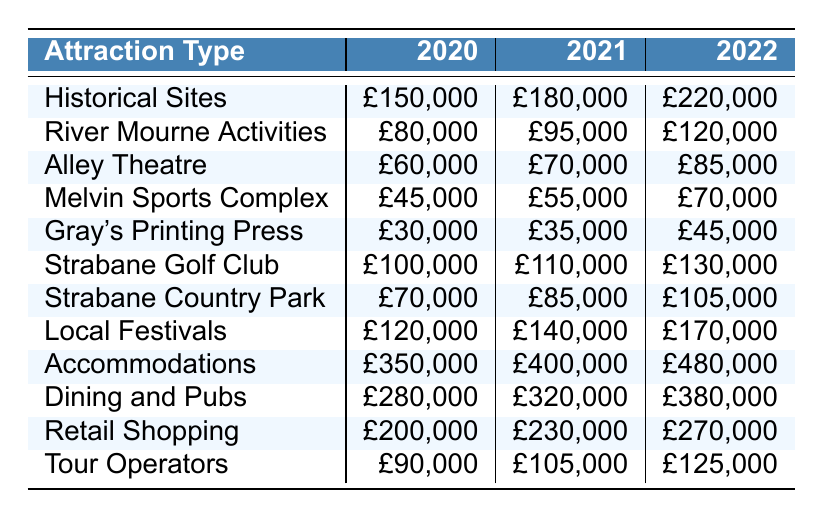What was the tourism revenue from Accommodations in 2022? The table shows that the revenue from Accommodations in 2022 is £480,000.
Answer: £480,000 Which attraction type had the highest revenue in 2021? By looking at the 2021 column, Accommodations has the highest revenue at £400,000.
Answer: Accommodations What is the total revenue from Dining and Pubs and Retail Shopping in 2020? The revenue for Dining and Pubs in 2020 is £280,000, and for Retail Shopping, it is £200,000. Summing these gives £280,000 + £200,000 = £480,000.
Answer: £480,000 Did the revenue from Strabane Golf Club increase from 2020 to 2021? The revenue in 2020 was £100,000, and in 2021 it increased to £110,000. Therefore, it did increase.
Answer: Yes What is the average revenue for Historical Sites over the three years? The revenues are £150,000, £180,000, and £220,000. The total is £150,000 + £180,000 + £220,000 = £550,000. The average is £550,000 / 3 = £183,333.33.
Answer: £183,333.33 What was the increase in revenue for River Mourne Activities from 2020 to 2022? The revenue in 2020 was £80,000 and in 2022 it is £120,000. The increase is £120,000 - £80,000 = £40,000.
Answer: £40,000 Which attraction type saw the largest percentage increase in revenue from 2021 to 2022? Calculate the percentage increase for each type, for instance, Local Festivals increased from £140,000 to £170,000, which is (170,000 - 140,000) / 140,000 * 100 = 21.43%. The largest increase is for Accommodations, from £400,000 to £480,000, which is (480,000 - 400,000) / 400,000 * 100 = 20%. After calculating for all, Local Festivals had the largest percentage increase.
Answer: Local Festivals What was the revenue for Tour Operators in 2020 compared to Strabane Country Park in 2021? The revenue for Tour Operators in 2020 was £90,000, and for Strabane Country Park in 2021 it was £85,000. Tour Operators revenue was higher.
Answer: Yes Is the total revenue from Historical Sites and Gray's Printing Press greater than that from Melvin Sports Complex in 2022? The revenue for Historical Sites in 2022 is £220,000 and for Gray's Printing Press is £45,000, thus total £220,000 + £45,000 = £265,000. Melvin Sports Complex is £70,000. Since £265,000 > £70,000, the total is indeed greater.
Answer: Yes 